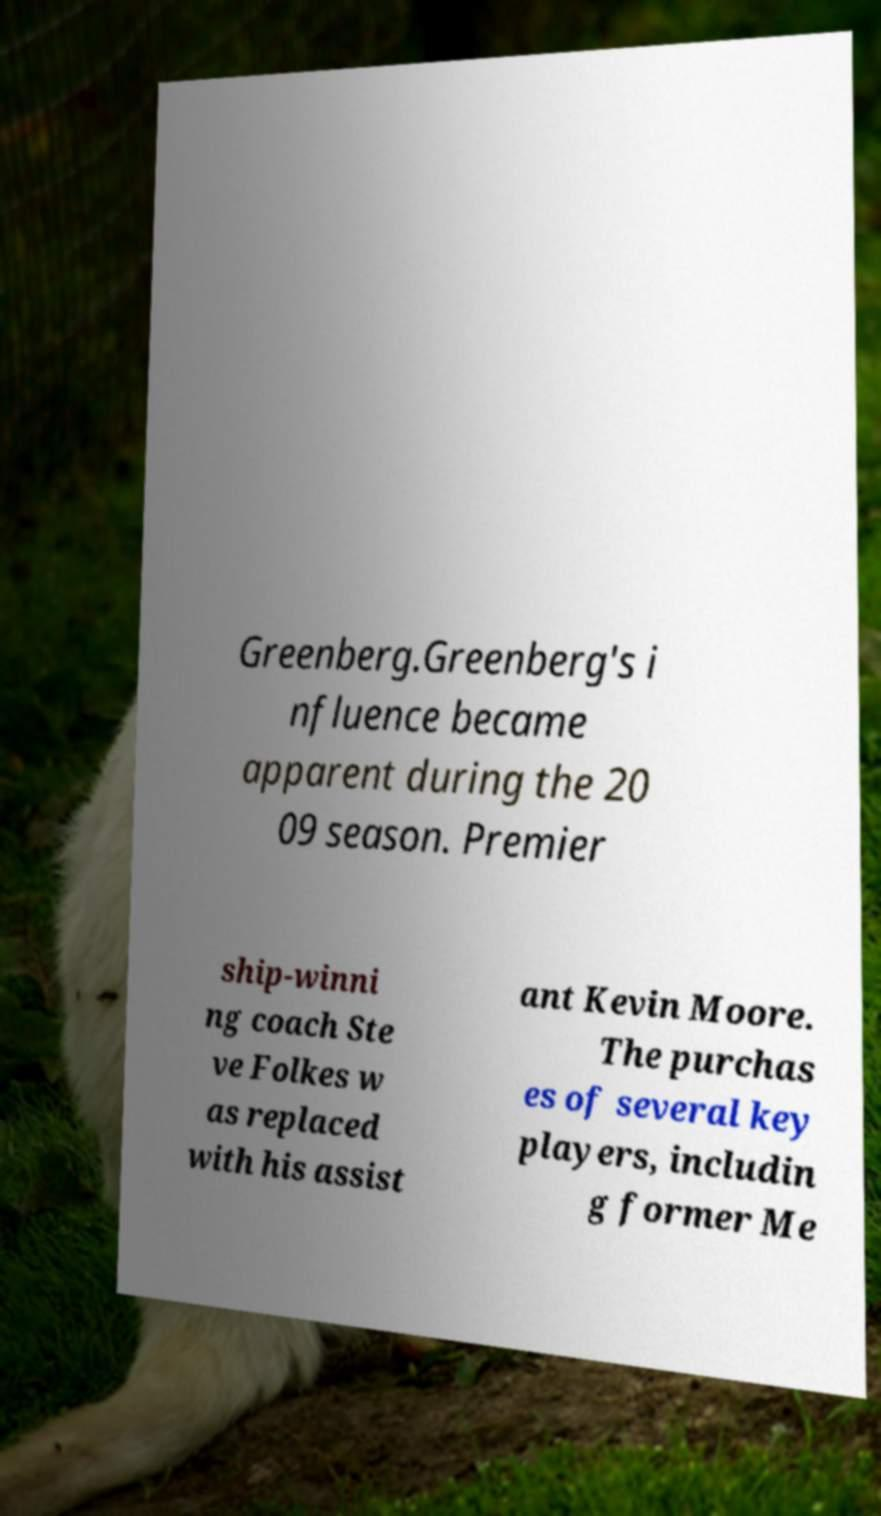Can you accurately transcribe the text from the provided image for me? Greenberg.Greenberg's i nfluence became apparent during the 20 09 season. Premier ship-winni ng coach Ste ve Folkes w as replaced with his assist ant Kevin Moore. The purchas es of several key players, includin g former Me 